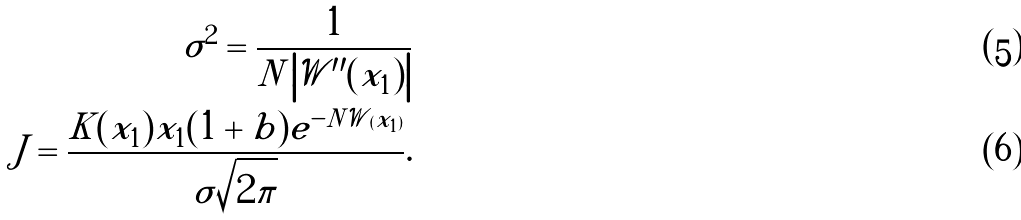Convert formula to latex. <formula><loc_0><loc_0><loc_500><loc_500>\sigma ^ { 2 } = \frac { 1 } { N \left | \mathcal { W } ^ { \prime \prime } ( x _ { 1 } ) \right | } \\ J = \frac { K ( x _ { 1 } ) x _ { 1 } ( 1 + b ) e ^ { - N \mathcal { W } ( x _ { 1 } ) } } { \sigma \sqrt { 2 \pi } } .</formula> 